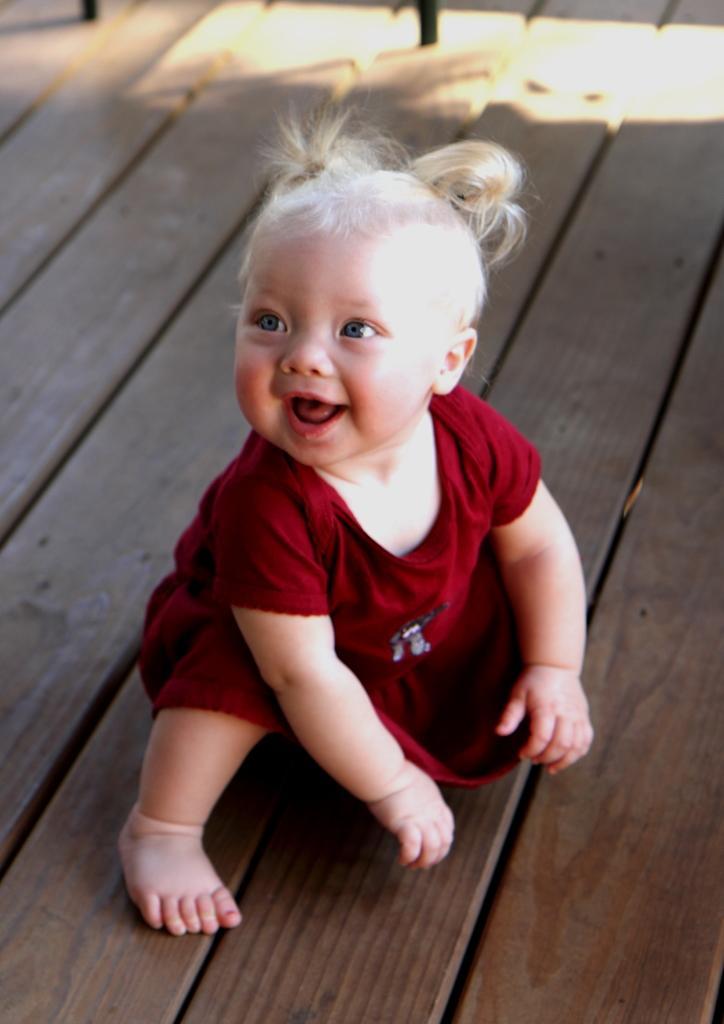In one or two sentences, can you explain what this image depicts? In this image there is a baby girl on the wooden platform. 